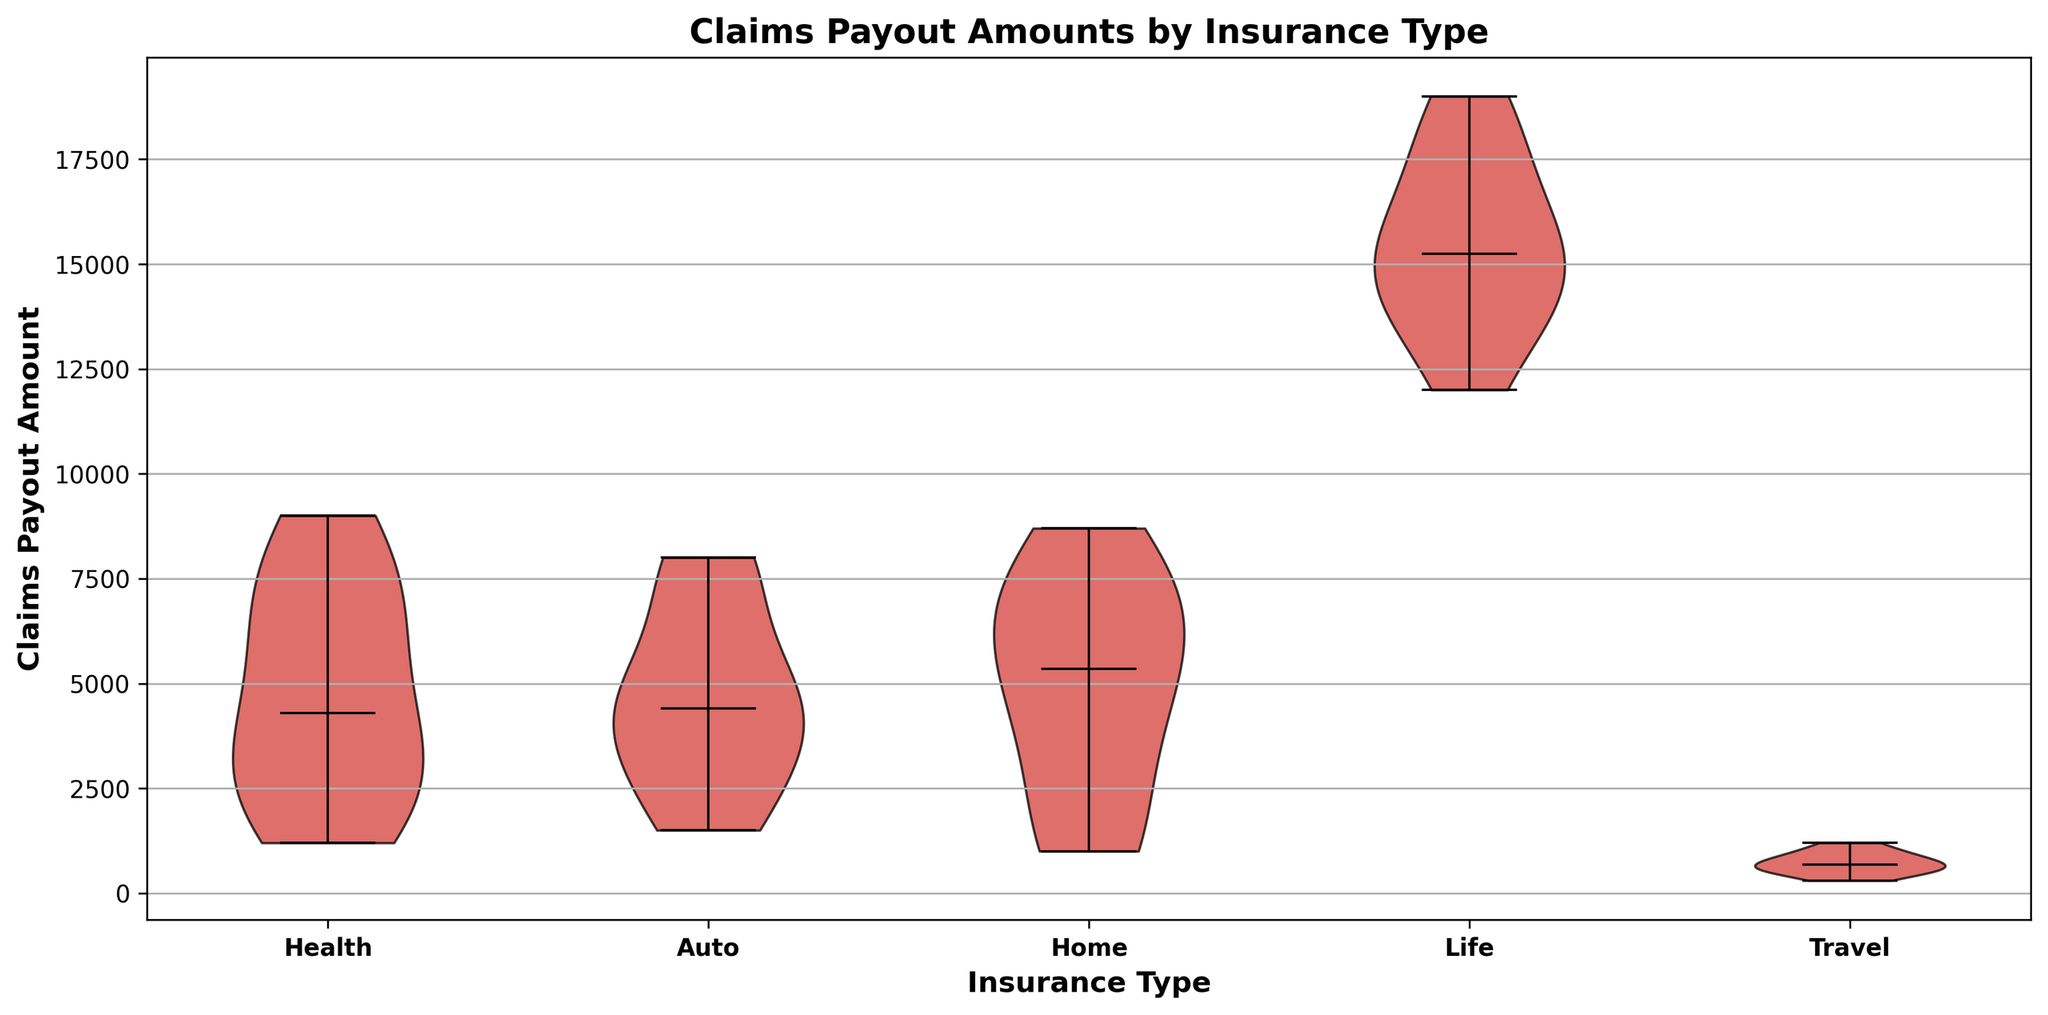Which insurance type has the highest median claims payout amount? By examining the median lines in the violin plots, we see that the median payout for Life insurance is higher than the medians for Health, Auto, Home, and Travel insurance.
Answer: Life Which insurance type shows the greatest range of claims payout amounts? The range of claims payouts can be inferred from the spread of the violin plots. Life insurance has the widest spread from the minimum to the maximum payout amount compared to other insurance types.
Answer: Life Is the median claims payout amount for Auto insurance higher than that for Health insurance? By comparing the median lines in the Auto and Health violin plots, we see that the median for Auto insurance is higher than the median for Health insurance.
Answer: Yes Do any of the insurance types show skewed distributions in their claims payouts? Skewness can be observed if the distribution is more spread on one side of the median. Health and Auto insurances show slightly right-skewed distributions; Life insurance shows a less skewed distribution.
Answer: Yes What is the approximate median payout amount for Travel insurance? The median payout for Travel insurance can be found by looking at the central horizontal line inside the violin plot. It is around 700.
Answer: 700 Which insurance type has the smallest variance in claims payout amounts? Variance can be visually assessed by how wide the violin plot spreads. The Travel insurance plot is the narrowest, indicating the smallest variance in claims payouts.
Answer: Travel Are there any insurance types where the median claims payout is higher than the 75th percentile of Travel insurance claims payout? The 75th percentile in Travel insurance is the upper extent of the central part of its distribution. This value appears to be around 900. All insurance types except for Travel have median payouts higher than this value.
Answer: Yes How do the payouts for Home insurance compare to those for Auto insurance in terms of median and range? The median payout for Home insurance is slightly higher than for Auto insurance. However, Auto insurance shows a wider range in the dataset compared to Home insurance. Home ranges from 1000 to 8700, while Auto ranges from 1500 to 8000.
Answer: Home has a higher median, Auto has a wider range For which insurance type is the interquartile range (IQR) the largest? The IQR is the middle 50% of data points (from the 25th to the 75th percentile). Life insurance clearly has the largest IQR as its violin plot shows the most significant spread in the middle 50% of its data.
Answer: Life Based on the visual attributes of the violin plots, which insurance type would likely have the least consistency in payout amounts? Consistency can be interpreted from the narrowness of the violin plot. The wider and more spread out the plot, the less consistent the payouts. Life insurance, given its wide range and spread, indicates the least consistency.
Answer: Life 